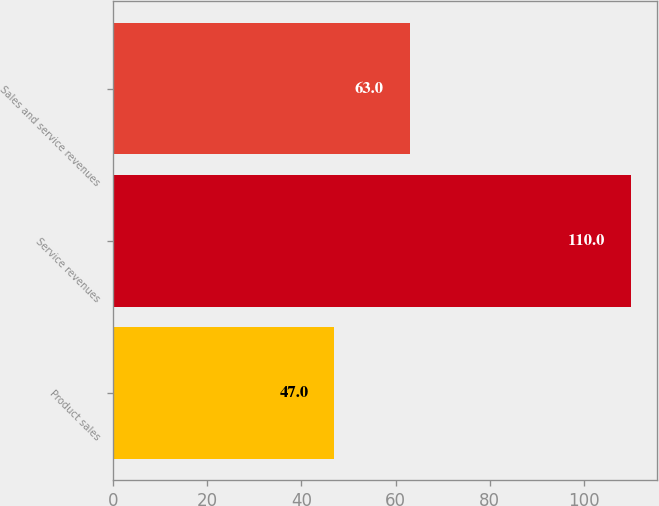Convert chart to OTSL. <chart><loc_0><loc_0><loc_500><loc_500><bar_chart><fcel>Product sales<fcel>Service revenues<fcel>Sales and service revenues<nl><fcel>47<fcel>110<fcel>63<nl></chart> 